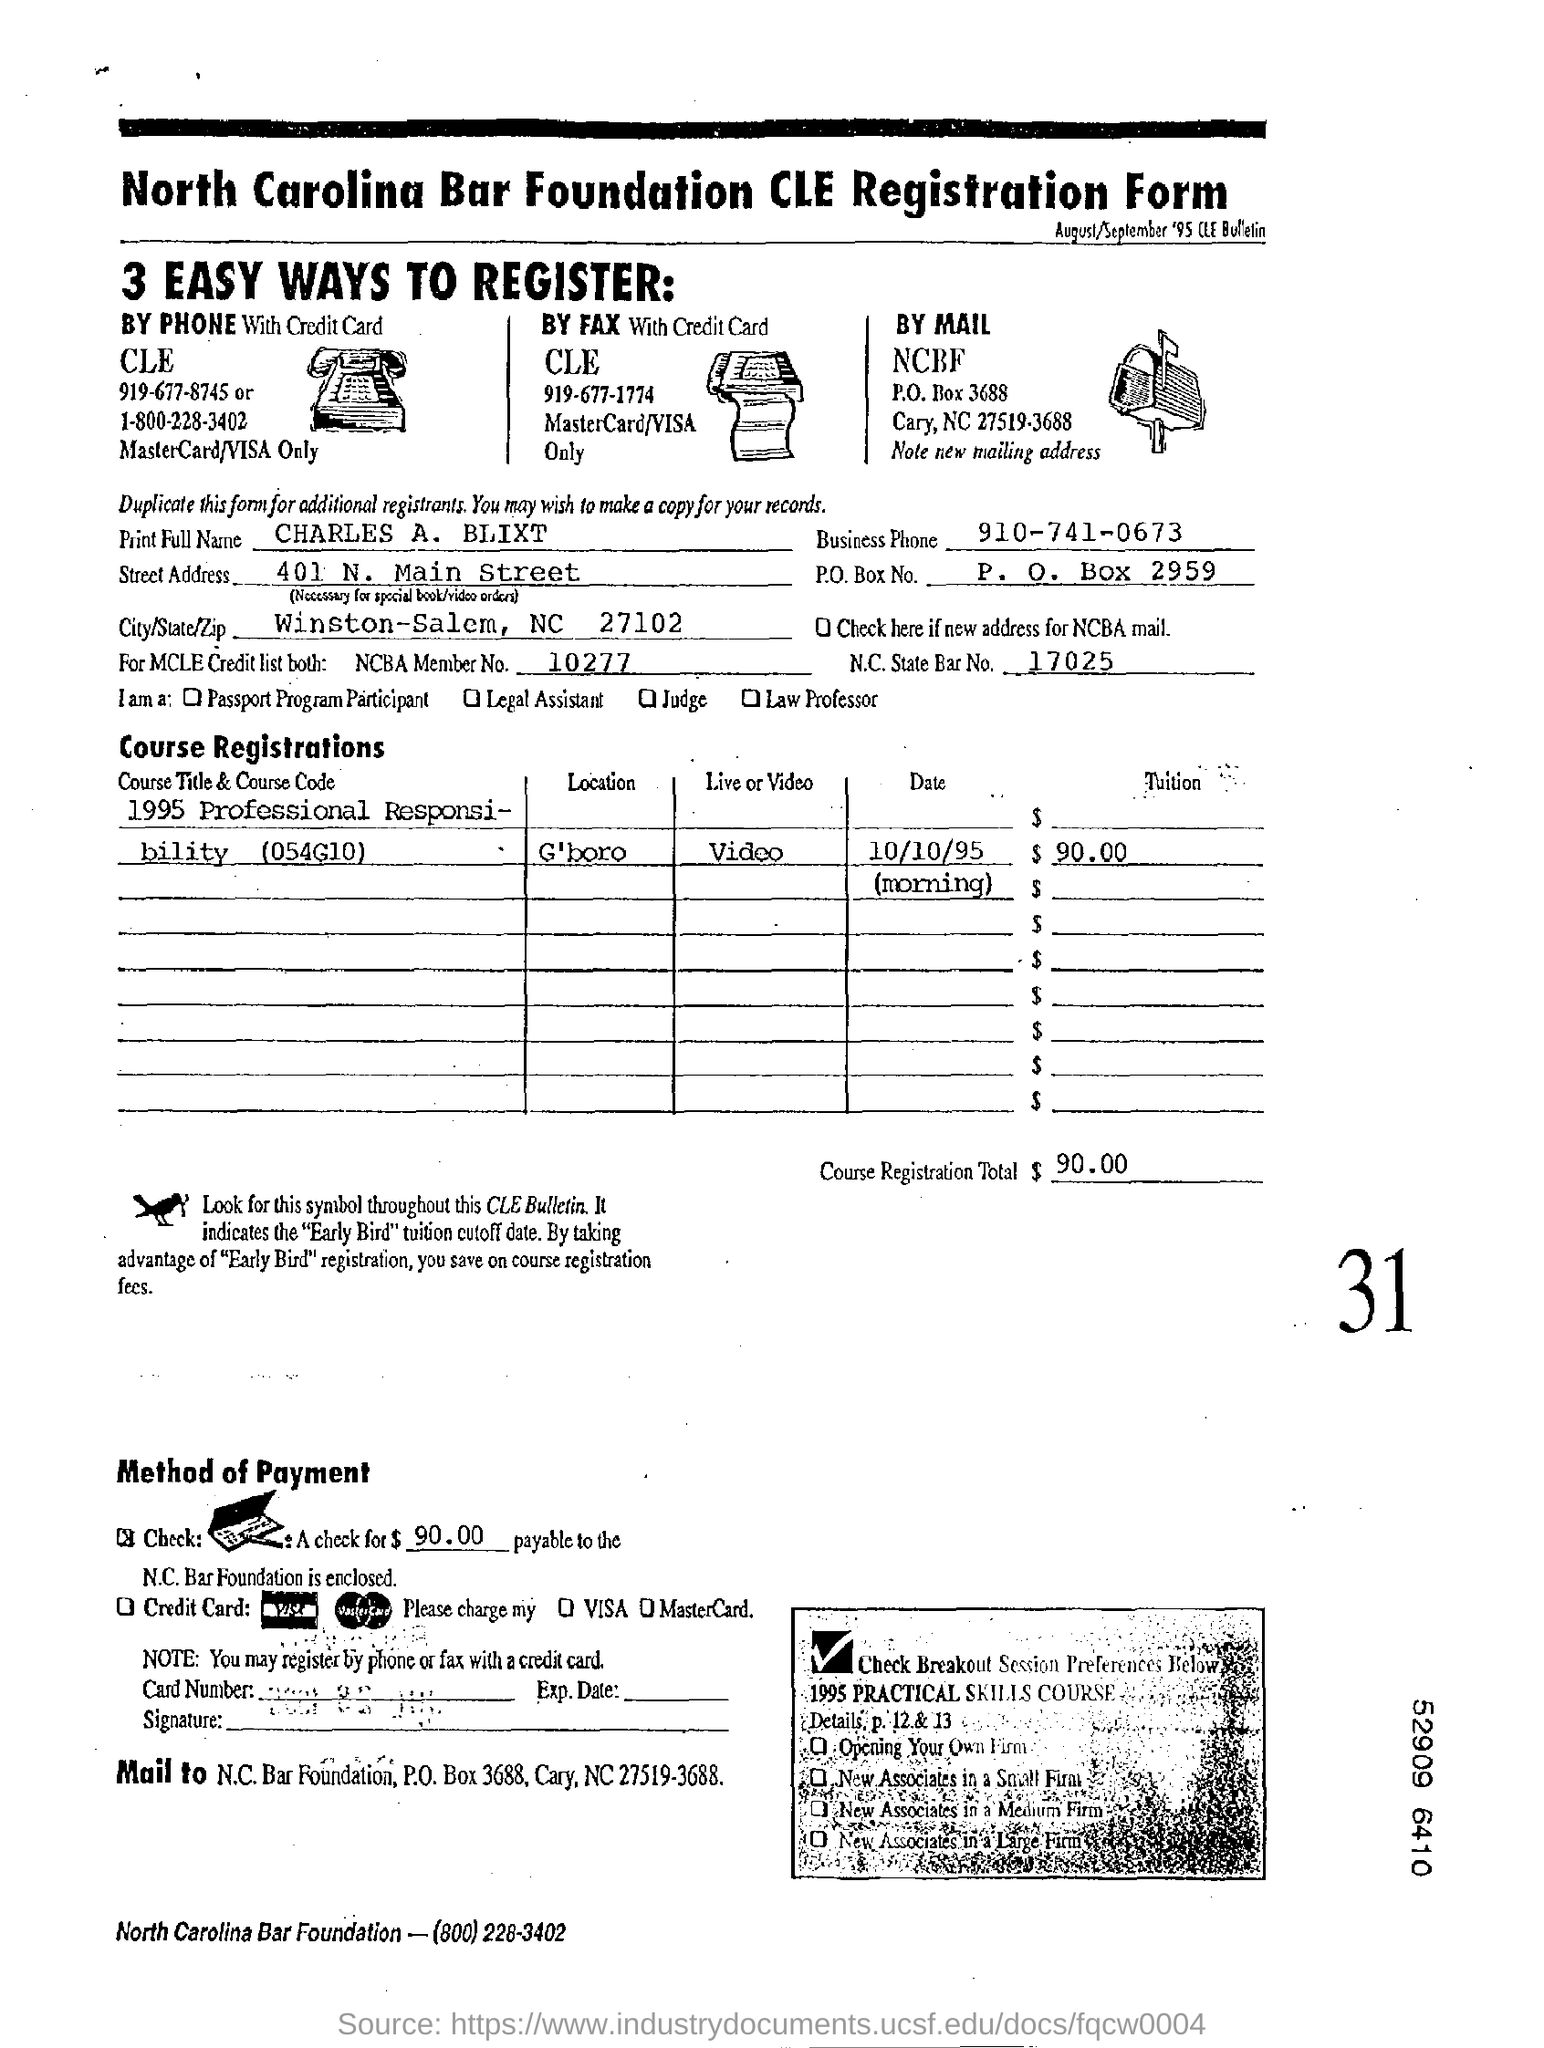List a handful of essential elements in this visual. The North Carolina Bar Foundation is the name of the foundation. The mode of payment is check. There are three ways mentioned to register. The NCBA member number is 10277. 